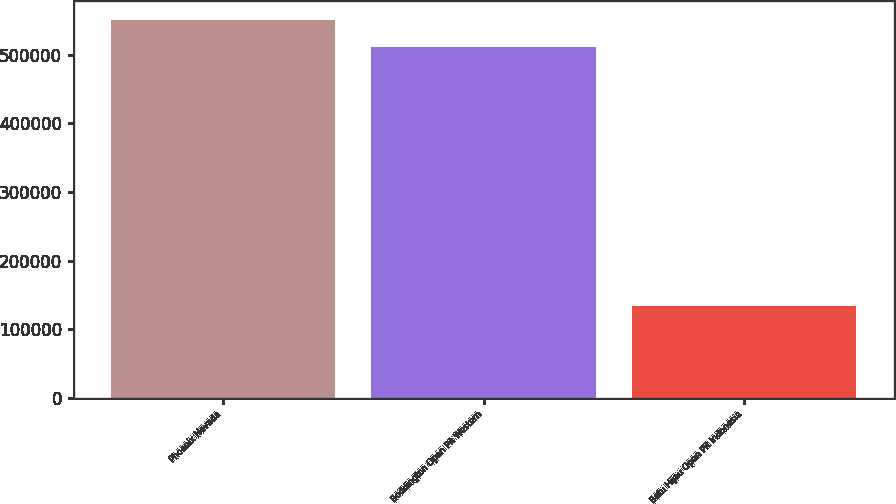Convert chart to OTSL. <chart><loc_0><loc_0><loc_500><loc_500><bar_chart><fcel>Phoenix Nevada<fcel>Boddington Open Pit Western<fcel>Batu Hijau Open Pit Indonesia<nl><fcel>550990<fcel>511700<fcel>134500<nl></chart> 